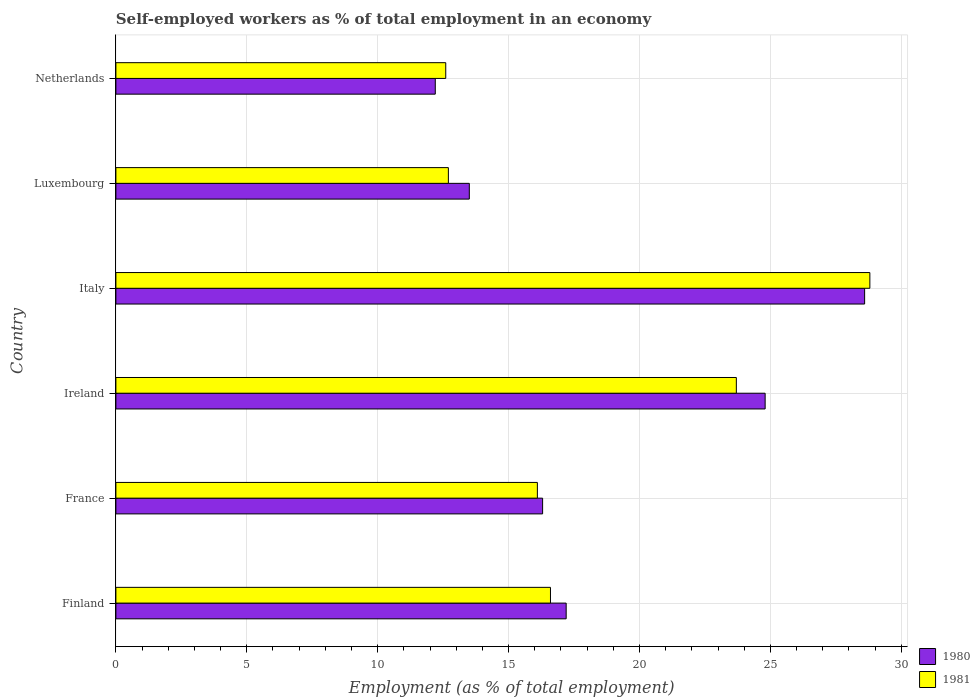How many different coloured bars are there?
Your answer should be very brief. 2. How many groups of bars are there?
Your answer should be compact. 6. Are the number of bars per tick equal to the number of legend labels?
Offer a terse response. Yes. How many bars are there on the 4th tick from the top?
Offer a terse response. 2. How many bars are there on the 5th tick from the bottom?
Make the answer very short. 2. What is the label of the 6th group of bars from the top?
Keep it short and to the point. Finland. In how many cases, is the number of bars for a given country not equal to the number of legend labels?
Give a very brief answer. 0. What is the percentage of self-employed workers in 1981 in France?
Give a very brief answer. 16.1. Across all countries, what is the maximum percentage of self-employed workers in 1980?
Your answer should be compact. 28.6. Across all countries, what is the minimum percentage of self-employed workers in 1981?
Your answer should be very brief. 12.6. In which country was the percentage of self-employed workers in 1981 minimum?
Provide a short and direct response. Netherlands. What is the total percentage of self-employed workers in 1981 in the graph?
Provide a short and direct response. 110.5. What is the difference between the percentage of self-employed workers in 1980 in Ireland and that in Netherlands?
Ensure brevity in your answer.  12.6. What is the difference between the percentage of self-employed workers in 1981 in Finland and the percentage of self-employed workers in 1980 in France?
Your answer should be compact. 0.3. What is the average percentage of self-employed workers in 1981 per country?
Ensure brevity in your answer.  18.42. What is the difference between the percentage of self-employed workers in 1980 and percentage of self-employed workers in 1981 in Ireland?
Make the answer very short. 1.1. In how many countries, is the percentage of self-employed workers in 1980 greater than 12 %?
Your answer should be very brief. 6. What is the ratio of the percentage of self-employed workers in 1980 in France to that in Italy?
Your answer should be very brief. 0.57. Is the difference between the percentage of self-employed workers in 1980 in Ireland and Italy greater than the difference between the percentage of self-employed workers in 1981 in Ireland and Italy?
Give a very brief answer. Yes. What is the difference between the highest and the second highest percentage of self-employed workers in 1981?
Offer a terse response. 5.1. What is the difference between the highest and the lowest percentage of self-employed workers in 1980?
Ensure brevity in your answer.  16.4. What does the 2nd bar from the bottom in Ireland represents?
Ensure brevity in your answer.  1981. Does the graph contain grids?
Give a very brief answer. Yes. What is the title of the graph?
Your response must be concise. Self-employed workers as % of total employment in an economy. What is the label or title of the X-axis?
Offer a terse response. Employment (as % of total employment). What is the Employment (as % of total employment) in 1980 in Finland?
Provide a succinct answer. 17.2. What is the Employment (as % of total employment) of 1981 in Finland?
Provide a short and direct response. 16.6. What is the Employment (as % of total employment) of 1980 in France?
Your answer should be very brief. 16.3. What is the Employment (as % of total employment) of 1981 in France?
Offer a terse response. 16.1. What is the Employment (as % of total employment) in 1980 in Ireland?
Provide a short and direct response. 24.8. What is the Employment (as % of total employment) in 1981 in Ireland?
Provide a short and direct response. 23.7. What is the Employment (as % of total employment) of 1980 in Italy?
Provide a short and direct response. 28.6. What is the Employment (as % of total employment) of 1981 in Italy?
Give a very brief answer. 28.8. What is the Employment (as % of total employment) in 1980 in Luxembourg?
Your response must be concise. 13.5. What is the Employment (as % of total employment) of 1981 in Luxembourg?
Keep it short and to the point. 12.7. What is the Employment (as % of total employment) in 1980 in Netherlands?
Your answer should be compact. 12.2. What is the Employment (as % of total employment) of 1981 in Netherlands?
Your answer should be very brief. 12.6. Across all countries, what is the maximum Employment (as % of total employment) of 1980?
Keep it short and to the point. 28.6. Across all countries, what is the maximum Employment (as % of total employment) in 1981?
Make the answer very short. 28.8. Across all countries, what is the minimum Employment (as % of total employment) in 1980?
Offer a very short reply. 12.2. Across all countries, what is the minimum Employment (as % of total employment) of 1981?
Provide a short and direct response. 12.6. What is the total Employment (as % of total employment) in 1980 in the graph?
Provide a succinct answer. 112.6. What is the total Employment (as % of total employment) in 1981 in the graph?
Offer a very short reply. 110.5. What is the difference between the Employment (as % of total employment) of 1980 in Finland and that in France?
Offer a very short reply. 0.9. What is the difference between the Employment (as % of total employment) in 1980 in Finland and that in Italy?
Offer a very short reply. -11.4. What is the difference between the Employment (as % of total employment) in 1981 in Finland and that in Italy?
Your answer should be compact. -12.2. What is the difference between the Employment (as % of total employment) of 1981 in Finland and that in Luxembourg?
Your answer should be very brief. 3.9. What is the difference between the Employment (as % of total employment) of 1980 in Finland and that in Netherlands?
Make the answer very short. 5. What is the difference between the Employment (as % of total employment) in 1981 in Finland and that in Netherlands?
Offer a terse response. 4. What is the difference between the Employment (as % of total employment) of 1980 in France and that in Italy?
Keep it short and to the point. -12.3. What is the difference between the Employment (as % of total employment) in 1981 in France and that in Italy?
Provide a short and direct response. -12.7. What is the difference between the Employment (as % of total employment) in 1981 in France and that in Luxembourg?
Give a very brief answer. 3.4. What is the difference between the Employment (as % of total employment) of 1980 in France and that in Netherlands?
Keep it short and to the point. 4.1. What is the difference between the Employment (as % of total employment) of 1980 in Ireland and that in Italy?
Offer a very short reply. -3.8. What is the difference between the Employment (as % of total employment) in 1980 in Ireland and that in Luxembourg?
Provide a succinct answer. 11.3. What is the difference between the Employment (as % of total employment) of 1981 in Ireland and that in Luxembourg?
Provide a succinct answer. 11. What is the difference between the Employment (as % of total employment) in 1981 in Ireland and that in Netherlands?
Provide a succinct answer. 11.1. What is the difference between the Employment (as % of total employment) of 1980 in Italy and that in Luxembourg?
Ensure brevity in your answer.  15.1. What is the difference between the Employment (as % of total employment) of 1981 in Italy and that in Luxembourg?
Your response must be concise. 16.1. What is the difference between the Employment (as % of total employment) in 1981 in Luxembourg and that in Netherlands?
Offer a very short reply. 0.1. What is the difference between the Employment (as % of total employment) of 1980 in Finland and the Employment (as % of total employment) of 1981 in France?
Offer a very short reply. 1.1. What is the difference between the Employment (as % of total employment) of 1980 in Finland and the Employment (as % of total employment) of 1981 in Ireland?
Keep it short and to the point. -6.5. What is the difference between the Employment (as % of total employment) in 1980 in Finland and the Employment (as % of total employment) in 1981 in Italy?
Keep it short and to the point. -11.6. What is the difference between the Employment (as % of total employment) of 1980 in Finland and the Employment (as % of total employment) of 1981 in Luxembourg?
Give a very brief answer. 4.5. What is the difference between the Employment (as % of total employment) in 1980 in France and the Employment (as % of total employment) in 1981 in Ireland?
Keep it short and to the point. -7.4. What is the difference between the Employment (as % of total employment) of 1980 in France and the Employment (as % of total employment) of 1981 in Netherlands?
Your answer should be compact. 3.7. What is the difference between the Employment (as % of total employment) in 1980 in Ireland and the Employment (as % of total employment) in 1981 in Luxembourg?
Offer a very short reply. 12.1. What is the difference between the Employment (as % of total employment) of 1980 in Ireland and the Employment (as % of total employment) of 1981 in Netherlands?
Your response must be concise. 12.2. What is the difference between the Employment (as % of total employment) in 1980 in Italy and the Employment (as % of total employment) in 1981 in Luxembourg?
Give a very brief answer. 15.9. What is the difference between the Employment (as % of total employment) of 1980 in Luxembourg and the Employment (as % of total employment) of 1981 in Netherlands?
Your answer should be compact. 0.9. What is the average Employment (as % of total employment) of 1980 per country?
Offer a very short reply. 18.77. What is the average Employment (as % of total employment) in 1981 per country?
Your answer should be very brief. 18.42. What is the difference between the Employment (as % of total employment) of 1980 and Employment (as % of total employment) of 1981 in Finland?
Your response must be concise. 0.6. What is the difference between the Employment (as % of total employment) of 1980 and Employment (as % of total employment) of 1981 in Italy?
Ensure brevity in your answer.  -0.2. What is the difference between the Employment (as % of total employment) in 1980 and Employment (as % of total employment) in 1981 in Luxembourg?
Keep it short and to the point. 0.8. What is the ratio of the Employment (as % of total employment) of 1980 in Finland to that in France?
Your answer should be very brief. 1.06. What is the ratio of the Employment (as % of total employment) of 1981 in Finland to that in France?
Give a very brief answer. 1.03. What is the ratio of the Employment (as % of total employment) of 1980 in Finland to that in Ireland?
Your answer should be compact. 0.69. What is the ratio of the Employment (as % of total employment) of 1981 in Finland to that in Ireland?
Keep it short and to the point. 0.7. What is the ratio of the Employment (as % of total employment) of 1980 in Finland to that in Italy?
Provide a short and direct response. 0.6. What is the ratio of the Employment (as % of total employment) in 1981 in Finland to that in Italy?
Offer a terse response. 0.58. What is the ratio of the Employment (as % of total employment) in 1980 in Finland to that in Luxembourg?
Your answer should be very brief. 1.27. What is the ratio of the Employment (as % of total employment) of 1981 in Finland to that in Luxembourg?
Offer a terse response. 1.31. What is the ratio of the Employment (as % of total employment) in 1980 in Finland to that in Netherlands?
Your answer should be compact. 1.41. What is the ratio of the Employment (as % of total employment) of 1981 in Finland to that in Netherlands?
Make the answer very short. 1.32. What is the ratio of the Employment (as % of total employment) of 1980 in France to that in Ireland?
Make the answer very short. 0.66. What is the ratio of the Employment (as % of total employment) in 1981 in France to that in Ireland?
Your response must be concise. 0.68. What is the ratio of the Employment (as % of total employment) in 1980 in France to that in Italy?
Offer a terse response. 0.57. What is the ratio of the Employment (as % of total employment) in 1981 in France to that in Italy?
Your response must be concise. 0.56. What is the ratio of the Employment (as % of total employment) of 1980 in France to that in Luxembourg?
Offer a terse response. 1.21. What is the ratio of the Employment (as % of total employment) of 1981 in France to that in Luxembourg?
Your response must be concise. 1.27. What is the ratio of the Employment (as % of total employment) in 1980 in France to that in Netherlands?
Make the answer very short. 1.34. What is the ratio of the Employment (as % of total employment) in 1981 in France to that in Netherlands?
Your answer should be compact. 1.28. What is the ratio of the Employment (as % of total employment) of 1980 in Ireland to that in Italy?
Make the answer very short. 0.87. What is the ratio of the Employment (as % of total employment) in 1981 in Ireland to that in Italy?
Offer a very short reply. 0.82. What is the ratio of the Employment (as % of total employment) of 1980 in Ireland to that in Luxembourg?
Offer a terse response. 1.84. What is the ratio of the Employment (as % of total employment) of 1981 in Ireland to that in Luxembourg?
Keep it short and to the point. 1.87. What is the ratio of the Employment (as % of total employment) in 1980 in Ireland to that in Netherlands?
Keep it short and to the point. 2.03. What is the ratio of the Employment (as % of total employment) in 1981 in Ireland to that in Netherlands?
Your answer should be very brief. 1.88. What is the ratio of the Employment (as % of total employment) in 1980 in Italy to that in Luxembourg?
Your response must be concise. 2.12. What is the ratio of the Employment (as % of total employment) of 1981 in Italy to that in Luxembourg?
Your answer should be compact. 2.27. What is the ratio of the Employment (as % of total employment) of 1980 in Italy to that in Netherlands?
Provide a succinct answer. 2.34. What is the ratio of the Employment (as % of total employment) of 1981 in Italy to that in Netherlands?
Offer a very short reply. 2.29. What is the ratio of the Employment (as % of total employment) in 1980 in Luxembourg to that in Netherlands?
Your answer should be very brief. 1.11. What is the ratio of the Employment (as % of total employment) of 1981 in Luxembourg to that in Netherlands?
Make the answer very short. 1.01. What is the difference between the highest and the second highest Employment (as % of total employment) in 1980?
Provide a short and direct response. 3.8. What is the difference between the highest and the second highest Employment (as % of total employment) of 1981?
Ensure brevity in your answer.  5.1. 